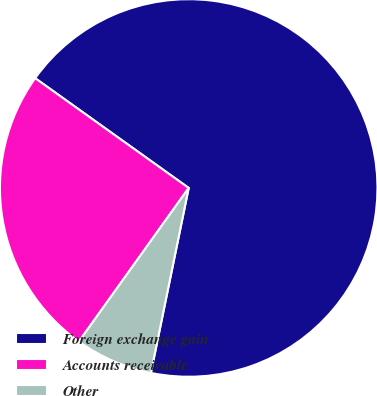Convert chart. <chart><loc_0><loc_0><loc_500><loc_500><pie_chart><fcel>Foreign exchange gain<fcel>Accounts receivable<fcel>Other<nl><fcel>68.33%<fcel>25.0%<fcel>6.67%<nl></chart> 